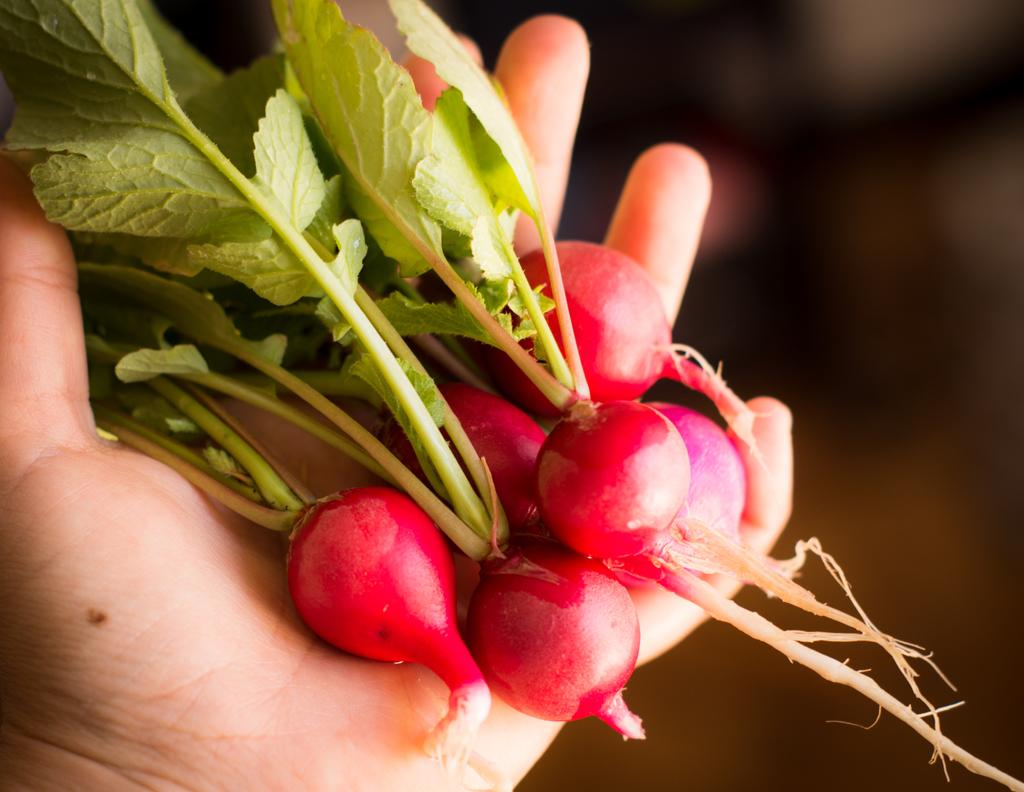What is present in the image? There is a person in the image. What is the person holding? The person is holding some vegetables. What type of stone is being used to boil water in the image? There is no stone or kettle present in the image; it only features a person holding vegetables. 